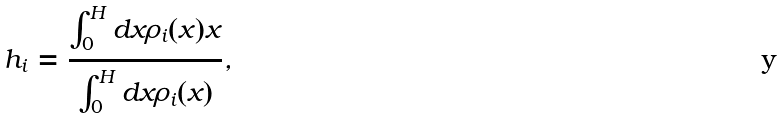<formula> <loc_0><loc_0><loc_500><loc_500>h _ { i } = \frac { \int _ { 0 } ^ { H } d x \rho _ { i } ( x ) x } { \int _ { 0 } ^ { H } d x \rho _ { i } ( x ) } ,</formula> 